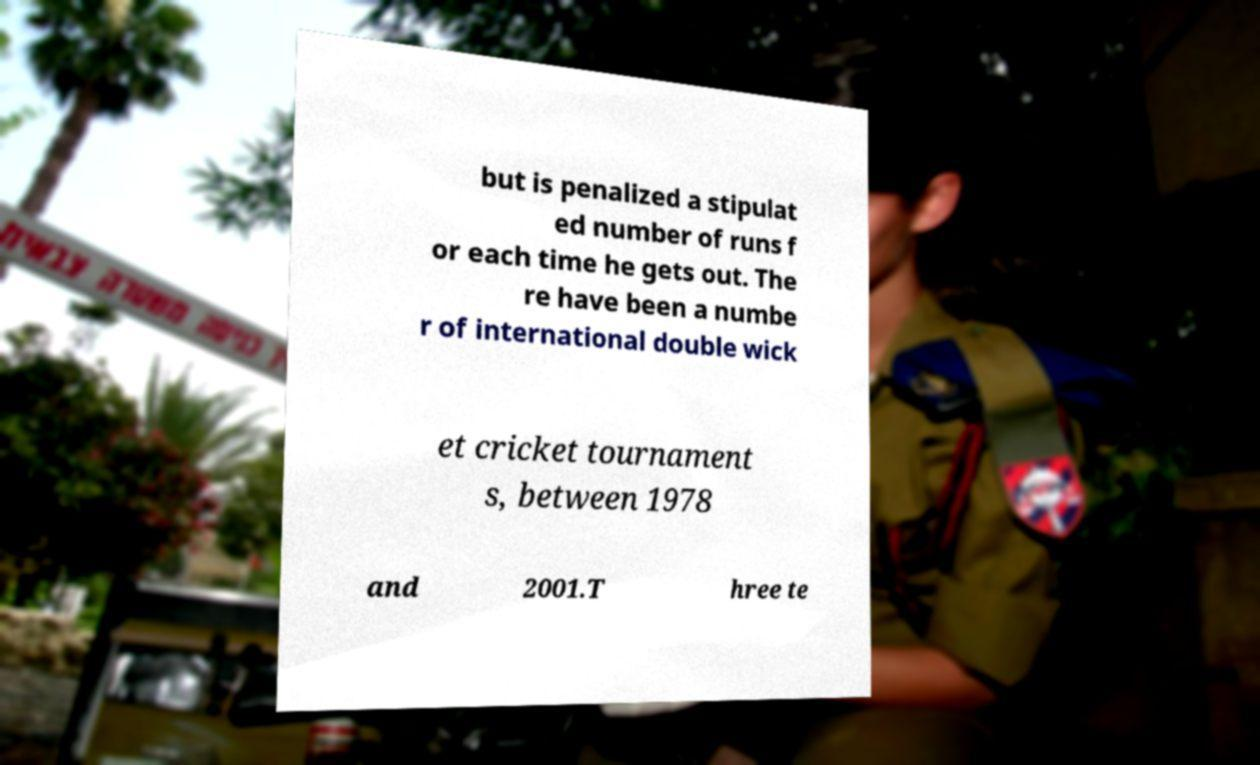Please identify and transcribe the text found in this image. but is penalized a stipulat ed number of runs f or each time he gets out. The re have been a numbe r of international double wick et cricket tournament s, between 1978 and 2001.T hree te 